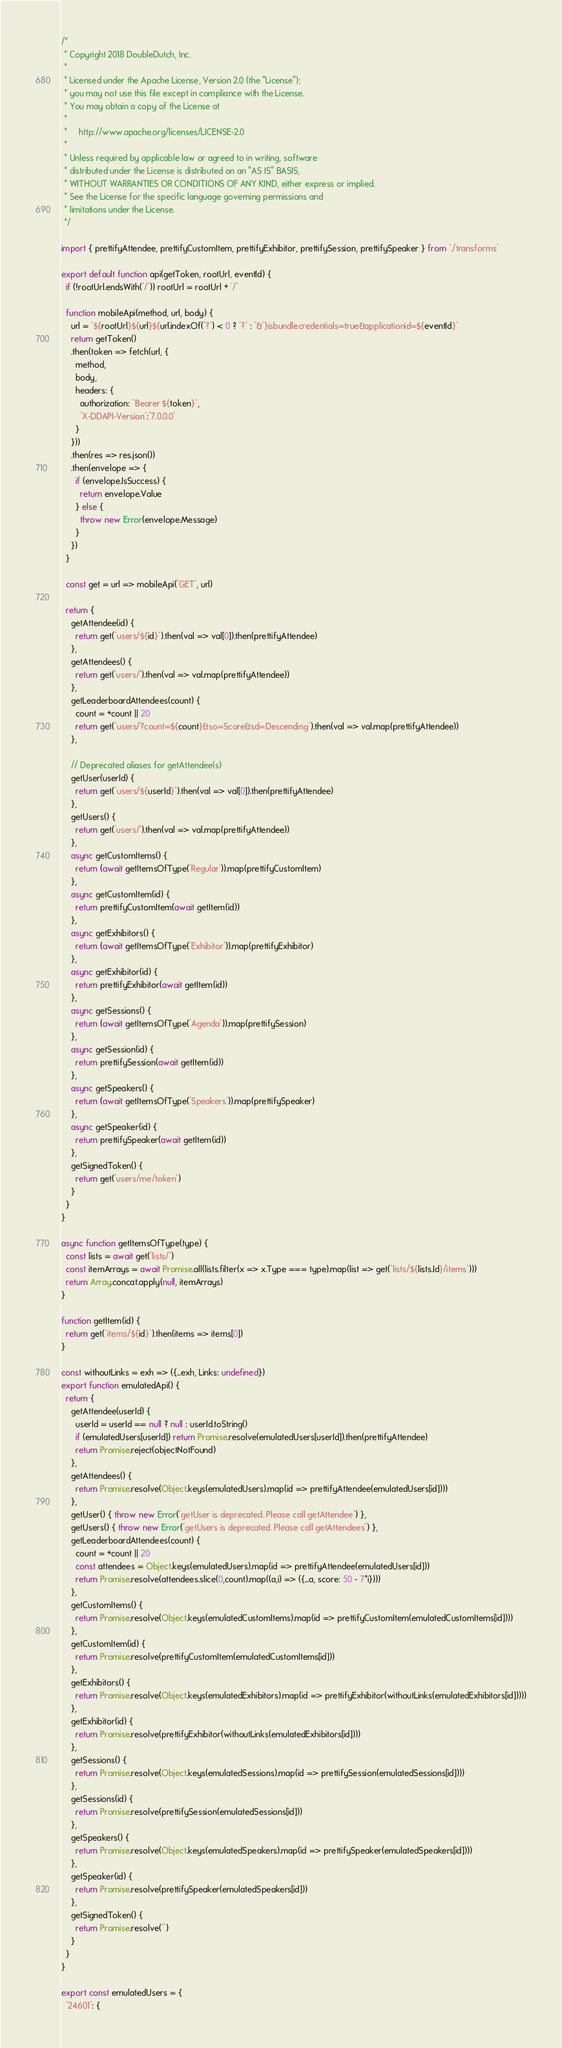Convert code to text. <code><loc_0><loc_0><loc_500><loc_500><_JavaScript_>/*
 * Copyright 2018 DoubleDutch, Inc.
 *
 * Licensed under the Apache License, Version 2.0 (the "License");
 * you may not use this file except in compliance with the License.
 * You may obtain a copy of the License at
 * 
 *     http://www.apache.org/licenses/LICENSE-2.0
 * 
 * Unless required by applicable law or agreed to in writing, software
 * distributed under the License is distributed on an "AS IS" BASIS,
 * WITHOUT WARRANTIES OR CONDITIONS OF ANY KIND, either express or implied.
 * See the License for the specific language governing permissions and
 * limitations under the License.
 */

import { prettifyAttendee, prettifyCustomItem, prettifyExhibitor, prettifySession, prettifySpeaker } from './transforms'

export default function api(getToken, rootUrl, eventId) {
  if (!rootUrl.endsWith('/')) rootUrl = rootUrl + '/'

  function mobileApi(method, url, body) {
    url = `${rootUrl}${url}${url.indexOf('?') < 0 ? '?' : '&'}isbundlecredentials=true&applicationid=${eventId}`
    return getToken()
    .then(token => fetch(url, {
      method,
      body,
      headers: {
        authorization: `Bearer ${token}`,
        'X-DDAPI-Version':'7.0.0.0'
      }
    }))
    .then(res => res.json())
    .then(envelope => {
      if (envelope.IsSuccess) {
        return envelope.Value
      } else {
        throw new Error(envelope.Message)
      }
    })
  }

  const get = url => mobileApi('GET', url)

  return {
    getAttendee(id) {
      return get(`users/${id}`).then(val => val[0]).then(prettifyAttendee)
    },
    getAttendees() {
      return get('users/').then(val => val.map(prettifyAttendee))
    },
    getLeaderboardAttendees(count) {
      count = +count || 20
      return get(`users/?count=${count}&so=Score&sd=Descending`).then(val => val.map(prettifyAttendee))
    },

    // Deprecated aliases for getAttendee(s)
    getUser(userId) {
      return get(`users/${userId}`).then(val => val[0]).then(prettifyAttendee)
    },
    getUsers() {
      return get('users/').then(val => val.map(prettifyAttendee))
    },
    async getCustomItems() {
      return (await getItemsOfType('Regular')).map(prettifyCustomItem)
    },
    async getCustomItem(id) {
      return prettifyCustomItem(await getItem(id))
    },
    async getExhibitors() {
      return (await getItemsOfType('Exhibitor')).map(prettifyExhibitor)
    },
    async getExhibitor(id) {
      return prettifyExhibitor(await getItem(id))
    },
    async getSessions() {
      return (await getItemsOfType('Agenda')).map(prettifySession)
    },
    async getSession(id) {
      return prettifySession(await getItem(id))
    },
    async getSpeakers() {
      return (await getItemsOfType('Speakers')).map(prettifySpeaker)
    },
    async getSpeaker(id) {
      return prettifySpeaker(await getItem(id))
    },
    getSignedToken() {
      return get('users/me/token')
    }
  }
}

async function getItemsOfType(type) {
  const lists = await get('lists/')
  const itemArrays = await Promise.all(lists.filter(x => x.Type === type).map(list => get(`lists/${lists.Id}/items`)))
  return Array.concat.apply(null, itemArrays)
}

function getItem(id) {
  return get(`items/${id}`).then(items => items[0])
}

const withoutLinks = exh => ({...exh, Links: undefined})
export function emulatedApi() {
  return {
    getAttendee(userId) {
      userId = userId == null ? null : userId.toString()
      if (emulatedUsers[userId]) return Promise.resolve(emulatedUsers[userId]).then(prettifyAttendee)
      return Promise.reject(objectNotFound)
    },
    getAttendees() {
      return Promise.resolve(Object.keys(emulatedUsers).map(id => prettifyAttendee(emulatedUsers[id])))
    },
    getUser() { throw new Error('getUser is deprecated. Please call getAttendee') },
    getUsers() { throw new Error('getUsers is deprecated. Please call getAttendees') },
    getLeaderboardAttendees(count) {
      count = +count || 20
      const attendees = Object.keys(emulatedUsers).map(id => prettifyAttendee(emulatedUsers[id]))
      return Promise.resolve(attendees.slice(0,count).map((a,i) => ({...a, score: 50 - 7*i})))
    },
    getCustomItems() {
      return Promise.resolve(Object.keys(emulatedCustomItems).map(id => prettifyCustomItem(emulatedCustomItems[id])))
    },
    getCustomItem(id) {
      return Promise.resolve(prettifyCustomItem(emulatedCustomItems[id]))
    },
    getExhibitors() {
      return Promise.resolve(Object.keys(emulatedExhibitors).map(id => prettifyExhibitor(withoutLinks(emulatedExhibitors[id]))))
    },
    getExhibitor(id) {
      return Promise.resolve(prettifyExhibitor(withoutLinks(emulatedExhibitors[id])))
    },
    getSessions() {
      return Promise.resolve(Object.keys(emulatedSessions).map(id => prettifySession(emulatedSessions[id])))
    },
    getSessions(id) {
      return Promise.resolve(prettifySession(emulatedSessions[id]))
    },
    getSpeakers() {
      return Promise.resolve(Object.keys(emulatedSpeakers).map(id => prettifySpeaker(emulatedSpeakers[id])))
    },
    getSpeaker(id) {
      return Promise.resolve(prettifySpeaker(emulatedSpeakers[id]))
    },
    getSignedToken() {
      return Promise.resolve('')
    }
  }
}

export const emulatedUsers = {
  '24601': {</code> 